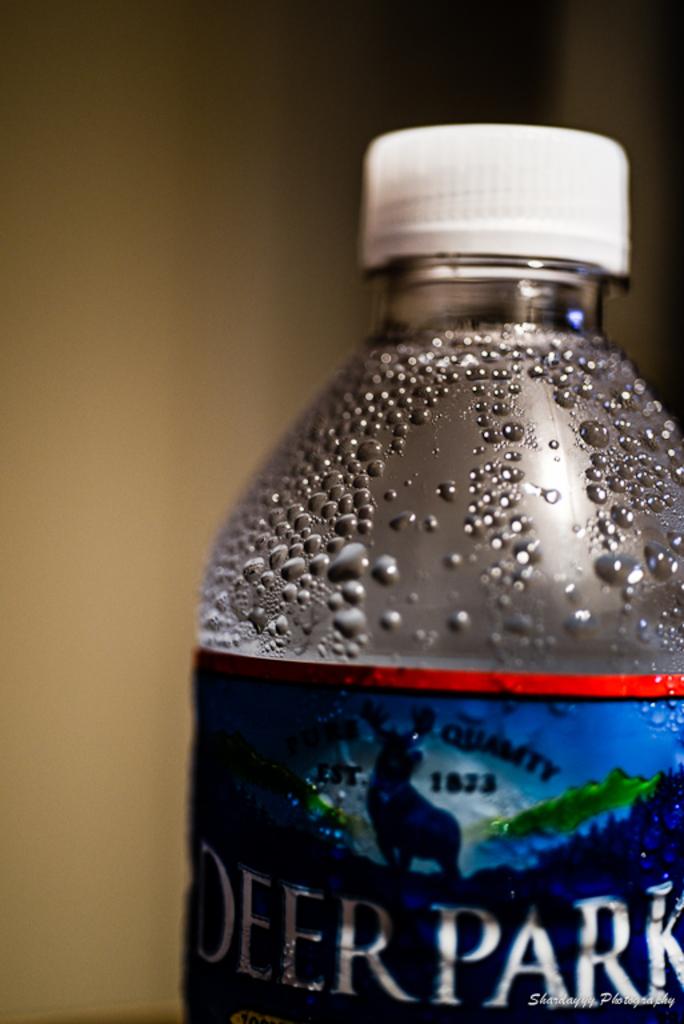What year was the bottled water company established?
Your answer should be very brief. 1873. 